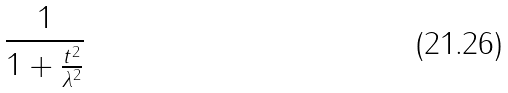<formula> <loc_0><loc_0><loc_500><loc_500>\frac { 1 } { 1 + \frac { t ^ { 2 } } { \lambda ^ { 2 } } }</formula> 